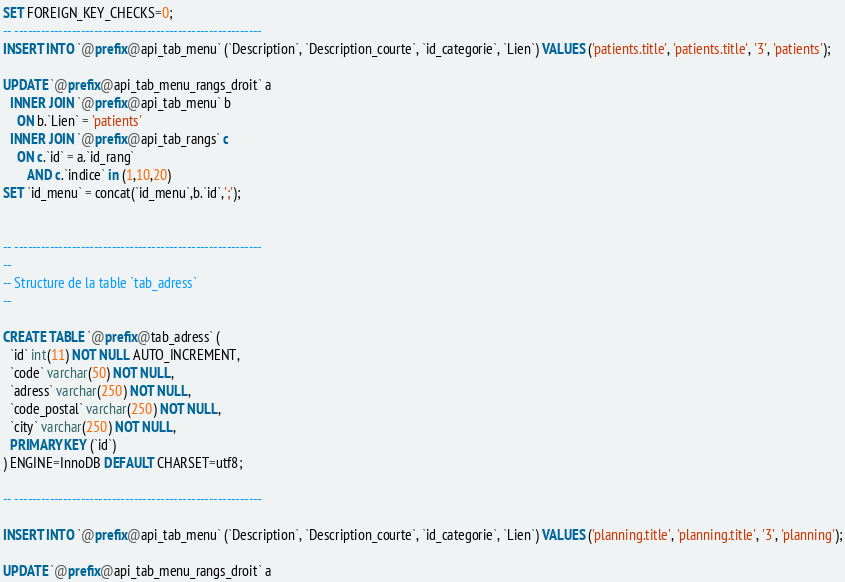<code> <loc_0><loc_0><loc_500><loc_500><_SQL_>SET FOREIGN_KEY_CHECKS=0;
-- --------------------------------------------------------
INSERT INTO `@prefix@api_tab_menu` (`Description`, `Description_courte`, `id_categorie`, `Lien`) VALUES ('patients.title', 'patients.title', '3', 'patients');

UPDATE `@prefix@api_tab_menu_rangs_droit` a
  INNER JOIN `@prefix@api_tab_menu` b
    ON b.`Lien` = 'patients'
  INNER JOIN `@prefix@api_tab_rangs` c
    ON c.`id` = a.`id_rang`
       AND c.`indice` in (1,10,20)
SET `id_menu` = concat(`id_menu`,b.`id`,';');


-- --------------------------------------------------------
--
-- Structure de la table `tab_adress`
--

CREATE TABLE `@prefix@tab_adress` (
  `id` int(11) NOT NULL AUTO_INCREMENT,
  `code` varchar(50) NOT NULL,
  `adress` varchar(250) NOT NULL,
  `code_postal` varchar(250) NOT NULL,
  `city` varchar(250) NOT NULL,
  PRIMARY KEY (`id`)
) ENGINE=InnoDB DEFAULT CHARSET=utf8;

-- --------------------------------------------------------

INSERT INTO `@prefix@api_tab_menu` (`Description`, `Description_courte`, `id_categorie`, `Lien`) VALUES ('planning.title', 'planning.title', '3', 'planning');

UPDATE `@prefix@api_tab_menu_rangs_droit` a</code> 